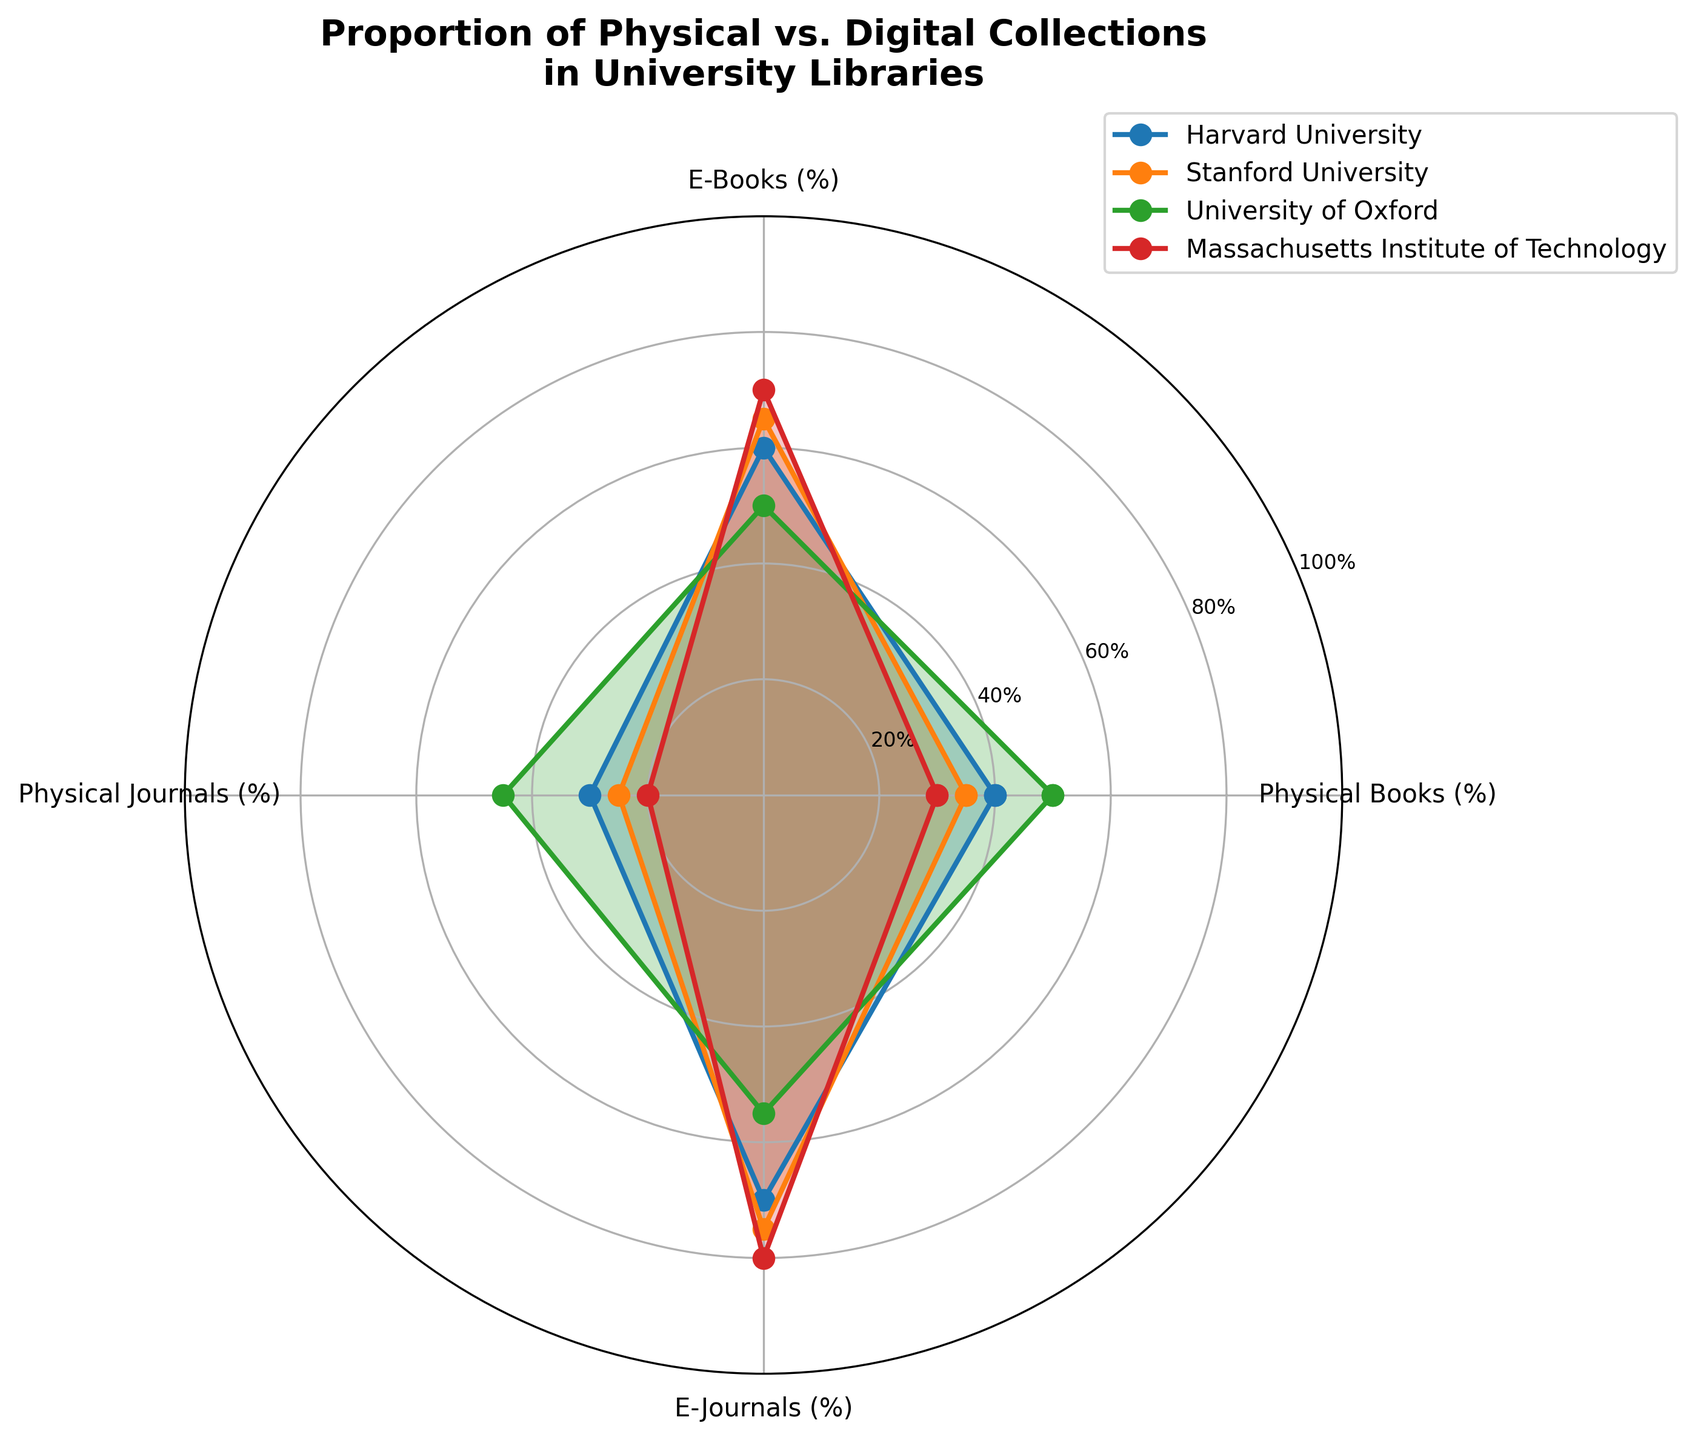What is the title of the radar chart? The title of the radar chart is prominently displayed at the top center of the figure.
Answer: Proportion of Physical vs. Digital Collections in University Libraries Which university has the highest proportion of E-Journals? By examining the values plotted for E-Journals, the university with the highest value for that category is identified.
Answer: Massachusetts Institute of Technology Compare the proportion of Physical Books at Stanford University and University of Oxford. Which one is higher? By looking at the plotted values for Physical Books on the radar chart, the figure for each university can be compared.
Answer: University of Oxford Calculate the average proportion of Physical Books among all four universities. The proportions of Physical Books are given as Harvard: 40%, Stanford: 35%, Oxford: 50%, MIT: 30%. The average can be found by summing these values and dividing by 4. (40 + 35 + 50 + 30)/4 = 38.75%
Answer: 38.75% Which university has an equal proportion of Physical Books and E-Books? By examining the plotted values for both Physical Books and E-Books, the university with equal values for both categories can be identified.
Answer: University of Oxford What is the overall trend in the proportion of Physical vs. Digital collections at MIT? By analyzing the plotted values for MIT, the proportions for physical and digital collections can be observed.
Answer: Higher proportion of digital collections than physical Compare the proportion of Physical Journals between Harvard University and Stanford University. Which one has a lower percentage? By comparing the values plotted for Physical Journals, the figures for each university allow for determining which one is lower.
Answer: Stanford University Which category shows the greatest variability among the universities? Variability can be observed by comparing the range of values within each category (Physical Books, E-Books, Physical Journals, E-Journals). The category with the largest difference between the highest and lowest values displays the greatest variability.
Answer: Physical Journals Identify the university with the closest balance between all four categories. The university with values for Physical Books, E-Books, Physical Journals, and E-Journals that are most similar to each other shows the closest balance.
Answer: University of Oxford 